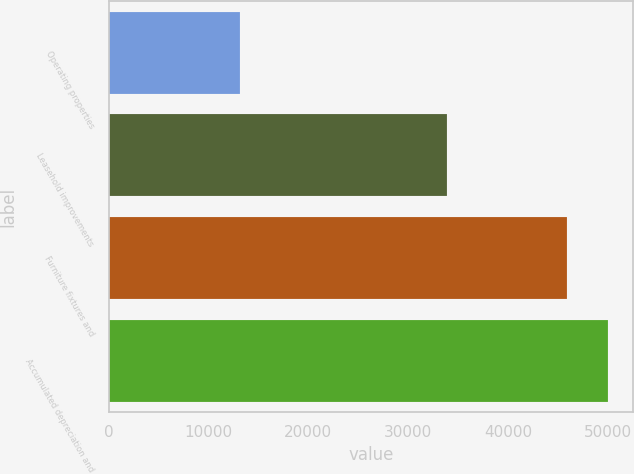<chart> <loc_0><loc_0><loc_500><loc_500><bar_chart><fcel>Operating properties<fcel>Leasehold improvements<fcel>Furniture fixtures and<fcel>Accumulated depreciation and<nl><fcel>13120<fcel>33896<fcel>45922<fcel>50061<nl></chart> 